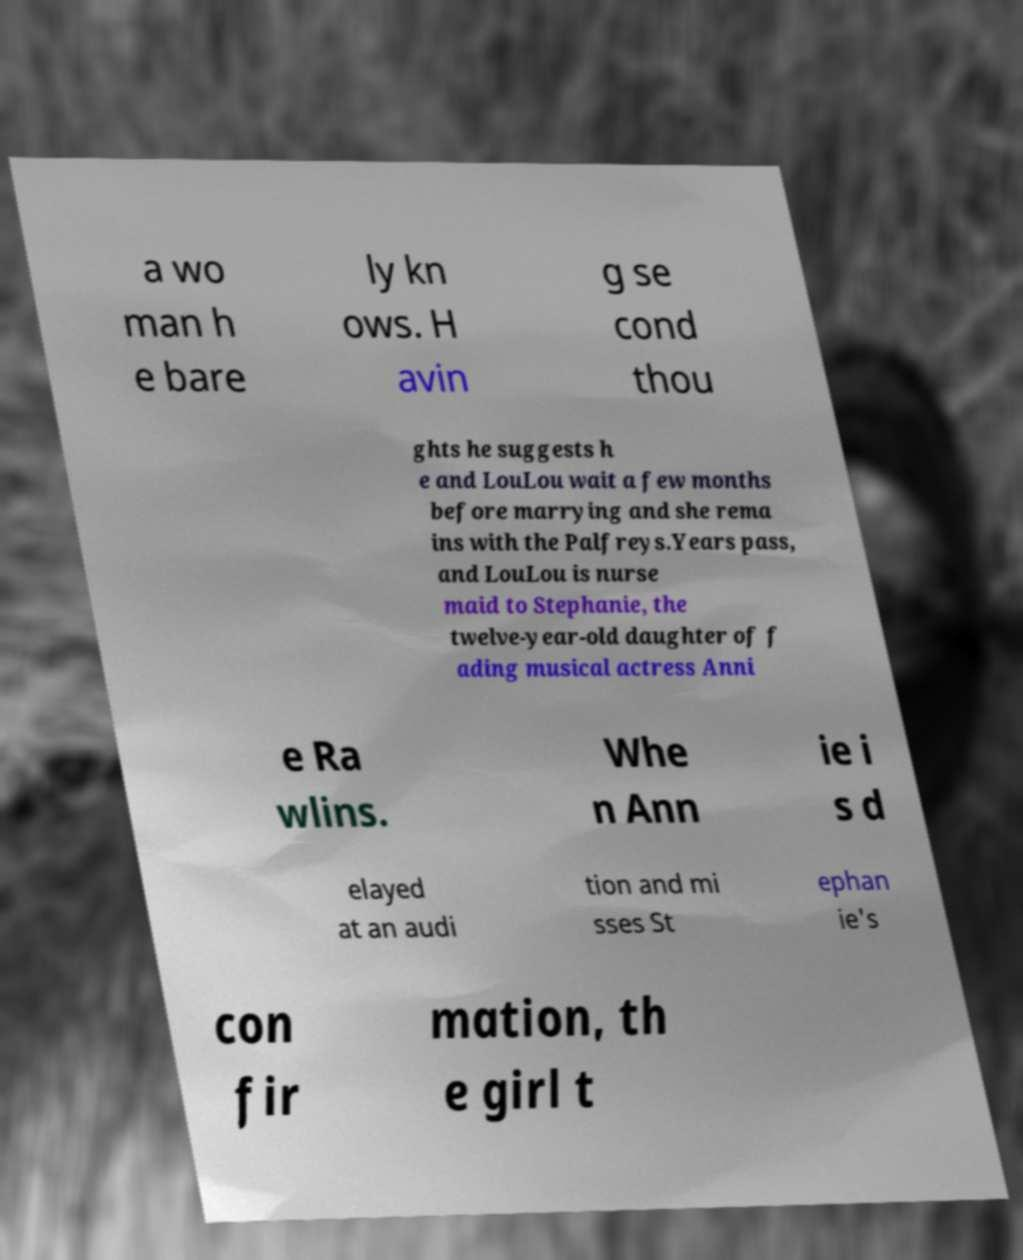Can you accurately transcribe the text from the provided image for me? a wo man h e bare ly kn ows. H avin g se cond thou ghts he suggests h e and LouLou wait a few months before marrying and she rema ins with the Palfreys.Years pass, and LouLou is nurse maid to Stephanie, the twelve-year-old daughter of f ading musical actress Anni e Ra wlins. Whe n Ann ie i s d elayed at an audi tion and mi sses St ephan ie's con fir mation, th e girl t 